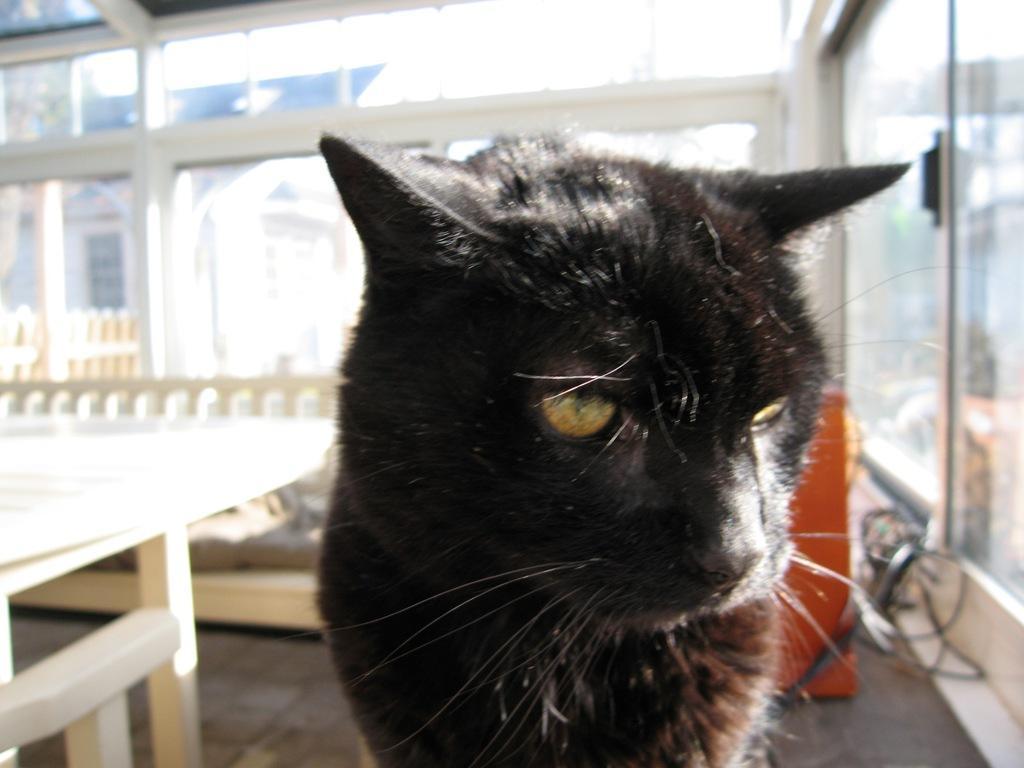Can you describe this image briefly? In the center of the image we can see a cat which is in black color. On the left there is a table. In the background we can see a door and there is a sofa. 